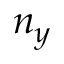Convert formula to latex. <formula><loc_0><loc_0><loc_500><loc_500>n _ { y }</formula> 